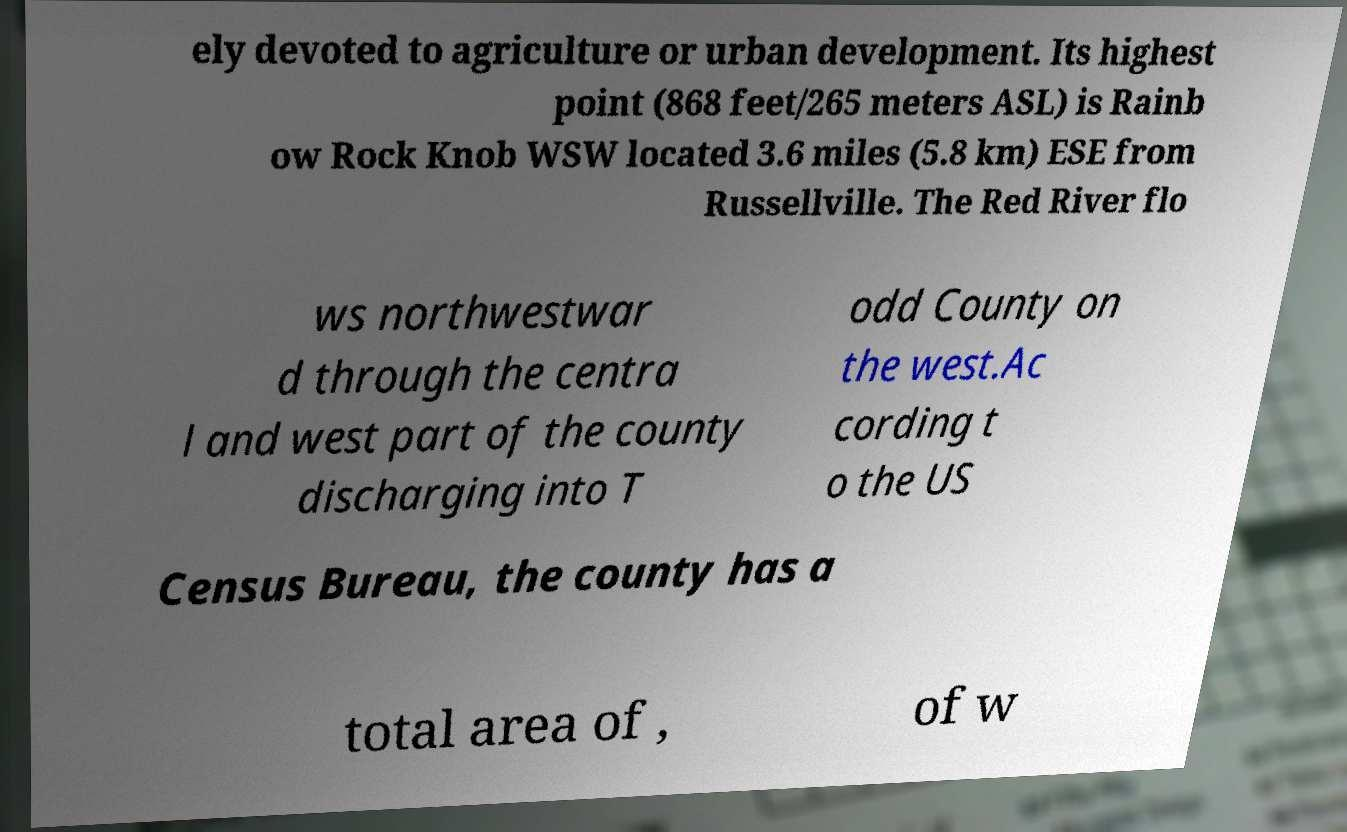Could you extract and type out the text from this image? ely devoted to agriculture or urban development. Its highest point (868 feet/265 meters ASL) is Rainb ow Rock Knob WSW located 3.6 miles (5.8 km) ESE from Russellville. The Red River flo ws northwestwar d through the centra l and west part of the county discharging into T odd County on the west.Ac cording t o the US Census Bureau, the county has a total area of , of w 